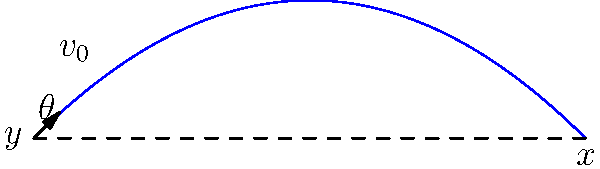During the 1980 Mississippi Valley State University football season, you observed a quarterback throw a perfect spiral pass. The ball left the quarterback's hand at an initial velocity of 25 m/s at a 45-degree angle to the horizontal. Neglecting air resistance and spin effects, what is the maximum height reached by the football during its flight? Let's approach this step-by-step:

1) The trajectory of the football follows a parabolic path, described by the equations of motion for projectile motion.

2) The vertical component of the motion determines the maximum height. We need to find the time when the vertical velocity becomes zero.

3) The initial vertical velocity is:
   $v_{0y} = v_0 \sin \theta = 25 \cdot \sin 45° = 25 \cdot \frac{\sqrt{2}}{2} \approx 17.68$ m/s

4) The time to reach the maximum height is given by:
   $t_{max} = \frac{v_{0y}}{g} = \frac{17.68}{9.8} \approx 1.80$ seconds

5) Now we can calculate the maximum height using the equation:
   $y_{max} = v_{0y}t - \frac{1}{2}gt^2$

6) Substituting the values:
   $y_{max} = 17.68 \cdot 1.80 - \frac{1}{2} \cdot 9.8 \cdot 1.80^2$
   $y_{max} = 31.82 - 15.91 = 15.91$ meters

Therefore, the maximum height reached by the football is approximately 15.91 meters.
Answer: 15.91 meters 